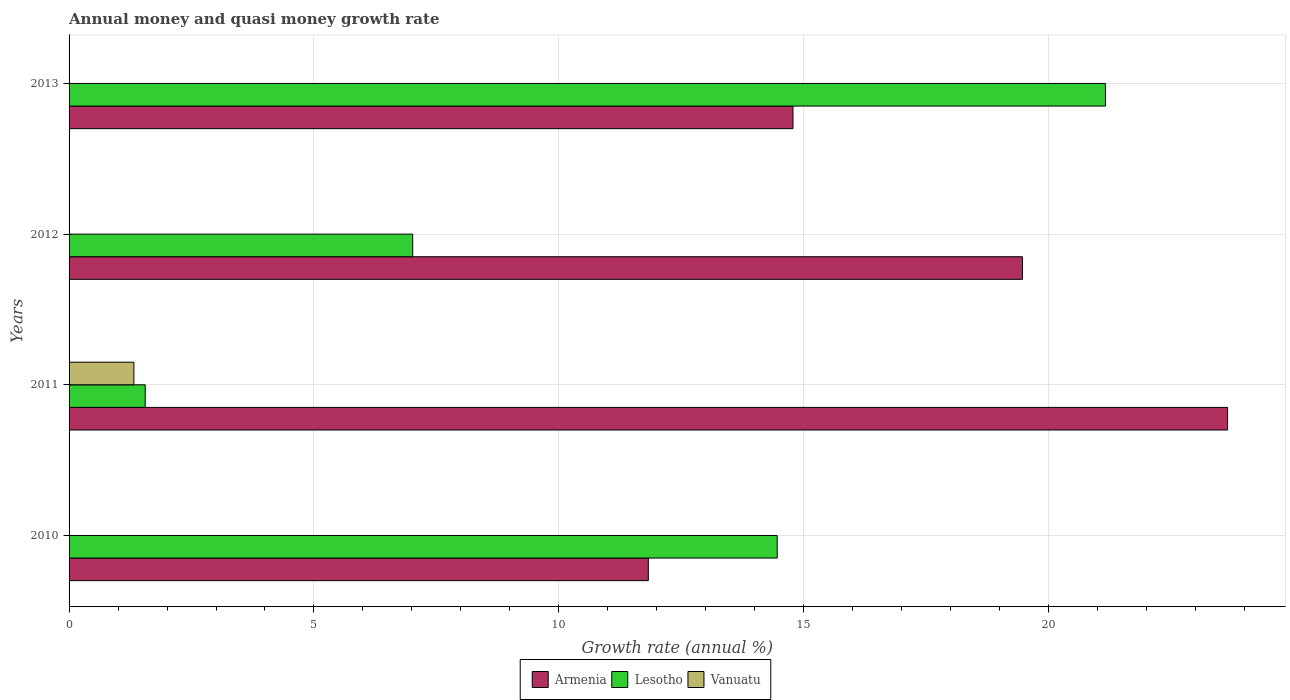How many bars are there on the 4th tick from the top?
Your answer should be compact. 2. How many bars are there on the 3rd tick from the bottom?
Provide a short and direct response. 2. In how many cases, is the number of bars for a given year not equal to the number of legend labels?
Give a very brief answer. 3. What is the growth rate in Armenia in 2013?
Offer a very short reply. 14.78. Across all years, what is the maximum growth rate in Vanuatu?
Offer a very short reply. 1.32. Across all years, what is the minimum growth rate in Armenia?
Make the answer very short. 11.83. In which year was the growth rate in Vanuatu maximum?
Give a very brief answer. 2011. What is the total growth rate in Vanuatu in the graph?
Give a very brief answer. 1.32. What is the difference between the growth rate in Lesotho in 2011 and that in 2013?
Provide a succinct answer. -19.61. What is the difference between the growth rate in Vanuatu in 2013 and the growth rate in Armenia in 2012?
Offer a very short reply. -19.47. What is the average growth rate in Vanuatu per year?
Your response must be concise. 0.33. In the year 2011, what is the difference between the growth rate in Vanuatu and growth rate in Armenia?
Offer a very short reply. -22.33. In how many years, is the growth rate in Armenia greater than 22 %?
Offer a terse response. 1. What is the ratio of the growth rate in Armenia in 2011 to that in 2012?
Offer a very short reply. 1.22. Is the growth rate in Armenia in 2011 less than that in 2012?
Your answer should be very brief. No. What is the difference between the highest and the second highest growth rate in Armenia?
Provide a short and direct response. 4.19. What is the difference between the highest and the lowest growth rate in Armenia?
Provide a succinct answer. 11.83. Is the sum of the growth rate in Lesotho in 2011 and 2012 greater than the maximum growth rate in Armenia across all years?
Give a very brief answer. No. Is it the case that in every year, the sum of the growth rate in Lesotho and growth rate in Armenia is greater than the growth rate in Vanuatu?
Offer a very short reply. Yes. How many bars are there?
Keep it short and to the point. 9. Are the values on the major ticks of X-axis written in scientific E-notation?
Keep it short and to the point. No. Does the graph contain any zero values?
Keep it short and to the point. Yes. Does the graph contain grids?
Offer a very short reply. Yes. Where does the legend appear in the graph?
Give a very brief answer. Bottom center. What is the title of the graph?
Ensure brevity in your answer.  Annual money and quasi money growth rate. Does "New Zealand" appear as one of the legend labels in the graph?
Give a very brief answer. No. What is the label or title of the X-axis?
Make the answer very short. Growth rate (annual %). What is the Growth rate (annual %) of Armenia in 2010?
Provide a succinct answer. 11.83. What is the Growth rate (annual %) in Lesotho in 2010?
Offer a terse response. 14.46. What is the Growth rate (annual %) in Vanuatu in 2010?
Your answer should be compact. 0. What is the Growth rate (annual %) in Armenia in 2011?
Offer a very short reply. 23.66. What is the Growth rate (annual %) in Lesotho in 2011?
Offer a very short reply. 1.55. What is the Growth rate (annual %) in Vanuatu in 2011?
Your answer should be compact. 1.32. What is the Growth rate (annual %) in Armenia in 2012?
Offer a very short reply. 19.47. What is the Growth rate (annual %) of Lesotho in 2012?
Your answer should be compact. 7.02. What is the Growth rate (annual %) of Armenia in 2013?
Ensure brevity in your answer.  14.78. What is the Growth rate (annual %) of Lesotho in 2013?
Your answer should be compact. 21.16. Across all years, what is the maximum Growth rate (annual %) of Armenia?
Provide a short and direct response. 23.66. Across all years, what is the maximum Growth rate (annual %) in Lesotho?
Offer a very short reply. 21.16. Across all years, what is the maximum Growth rate (annual %) in Vanuatu?
Your answer should be compact. 1.32. Across all years, what is the minimum Growth rate (annual %) of Armenia?
Make the answer very short. 11.83. Across all years, what is the minimum Growth rate (annual %) in Lesotho?
Provide a short and direct response. 1.55. Across all years, what is the minimum Growth rate (annual %) of Vanuatu?
Offer a terse response. 0. What is the total Growth rate (annual %) in Armenia in the graph?
Your response must be concise. 69.73. What is the total Growth rate (annual %) in Lesotho in the graph?
Offer a very short reply. 44.19. What is the total Growth rate (annual %) in Vanuatu in the graph?
Provide a succinct answer. 1.32. What is the difference between the Growth rate (annual %) of Armenia in 2010 and that in 2011?
Offer a terse response. -11.83. What is the difference between the Growth rate (annual %) in Lesotho in 2010 and that in 2011?
Offer a very short reply. 12.9. What is the difference between the Growth rate (annual %) of Armenia in 2010 and that in 2012?
Provide a short and direct response. -7.64. What is the difference between the Growth rate (annual %) in Lesotho in 2010 and that in 2012?
Make the answer very short. 7.44. What is the difference between the Growth rate (annual %) of Armenia in 2010 and that in 2013?
Make the answer very short. -2.95. What is the difference between the Growth rate (annual %) of Lesotho in 2010 and that in 2013?
Ensure brevity in your answer.  -6.7. What is the difference between the Growth rate (annual %) of Armenia in 2011 and that in 2012?
Offer a very short reply. 4.19. What is the difference between the Growth rate (annual %) of Lesotho in 2011 and that in 2012?
Keep it short and to the point. -5.46. What is the difference between the Growth rate (annual %) of Armenia in 2011 and that in 2013?
Make the answer very short. 8.87. What is the difference between the Growth rate (annual %) of Lesotho in 2011 and that in 2013?
Keep it short and to the point. -19.61. What is the difference between the Growth rate (annual %) in Armenia in 2012 and that in 2013?
Make the answer very short. 4.69. What is the difference between the Growth rate (annual %) of Lesotho in 2012 and that in 2013?
Ensure brevity in your answer.  -14.14. What is the difference between the Growth rate (annual %) in Armenia in 2010 and the Growth rate (annual %) in Lesotho in 2011?
Your response must be concise. 10.27. What is the difference between the Growth rate (annual %) of Armenia in 2010 and the Growth rate (annual %) of Vanuatu in 2011?
Make the answer very short. 10.5. What is the difference between the Growth rate (annual %) in Lesotho in 2010 and the Growth rate (annual %) in Vanuatu in 2011?
Your response must be concise. 13.14. What is the difference between the Growth rate (annual %) in Armenia in 2010 and the Growth rate (annual %) in Lesotho in 2012?
Your answer should be compact. 4.81. What is the difference between the Growth rate (annual %) of Armenia in 2010 and the Growth rate (annual %) of Lesotho in 2013?
Make the answer very short. -9.33. What is the difference between the Growth rate (annual %) in Armenia in 2011 and the Growth rate (annual %) in Lesotho in 2012?
Ensure brevity in your answer.  16.64. What is the difference between the Growth rate (annual %) of Armenia in 2011 and the Growth rate (annual %) of Lesotho in 2013?
Provide a short and direct response. 2.49. What is the difference between the Growth rate (annual %) of Armenia in 2012 and the Growth rate (annual %) of Lesotho in 2013?
Your answer should be compact. -1.69. What is the average Growth rate (annual %) of Armenia per year?
Your answer should be very brief. 17.43. What is the average Growth rate (annual %) in Lesotho per year?
Your answer should be very brief. 11.05. What is the average Growth rate (annual %) of Vanuatu per year?
Keep it short and to the point. 0.33. In the year 2010, what is the difference between the Growth rate (annual %) of Armenia and Growth rate (annual %) of Lesotho?
Provide a succinct answer. -2.63. In the year 2011, what is the difference between the Growth rate (annual %) of Armenia and Growth rate (annual %) of Lesotho?
Keep it short and to the point. 22.1. In the year 2011, what is the difference between the Growth rate (annual %) of Armenia and Growth rate (annual %) of Vanuatu?
Your answer should be compact. 22.33. In the year 2011, what is the difference between the Growth rate (annual %) of Lesotho and Growth rate (annual %) of Vanuatu?
Provide a succinct answer. 0.23. In the year 2012, what is the difference between the Growth rate (annual %) of Armenia and Growth rate (annual %) of Lesotho?
Keep it short and to the point. 12.45. In the year 2013, what is the difference between the Growth rate (annual %) in Armenia and Growth rate (annual %) in Lesotho?
Your response must be concise. -6.38. What is the ratio of the Growth rate (annual %) in Lesotho in 2010 to that in 2011?
Your response must be concise. 9.3. What is the ratio of the Growth rate (annual %) in Armenia in 2010 to that in 2012?
Keep it short and to the point. 0.61. What is the ratio of the Growth rate (annual %) in Lesotho in 2010 to that in 2012?
Keep it short and to the point. 2.06. What is the ratio of the Growth rate (annual %) in Armenia in 2010 to that in 2013?
Make the answer very short. 0.8. What is the ratio of the Growth rate (annual %) of Lesotho in 2010 to that in 2013?
Your answer should be compact. 0.68. What is the ratio of the Growth rate (annual %) in Armenia in 2011 to that in 2012?
Provide a short and direct response. 1.22. What is the ratio of the Growth rate (annual %) in Lesotho in 2011 to that in 2012?
Keep it short and to the point. 0.22. What is the ratio of the Growth rate (annual %) in Armenia in 2011 to that in 2013?
Ensure brevity in your answer.  1.6. What is the ratio of the Growth rate (annual %) in Lesotho in 2011 to that in 2013?
Your answer should be very brief. 0.07. What is the ratio of the Growth rate (annual %) of Armenia in 2012 to that in 2013?
Your response must be concise. 1.32. What is the ratio of the Growth rate (annual %) in Lesotho in 2012 to that in 2013?
Your answer should be compact. 0.33. What is the difference between the highest and the second highest Growth rate (annual %) of Armenia?
Offer a terse response. 4.19. What is the difference between the highest and the second highest Growth rate (annual %) of Lesotho?
Offer a very short reply. 6.7. What is the difference between the highest and the lowest Growth rate (annual %) of Armenia?
Offer a terse response. 11.83. What is the difference between the highest and the lowest Growth rate (annual %) of Lesotho?
Offer a terse response. 19.61. What is the difference between the highest and the lowest Growth rate (annual %) in Vanuatu?
Offer a very short reply. 1.32. 